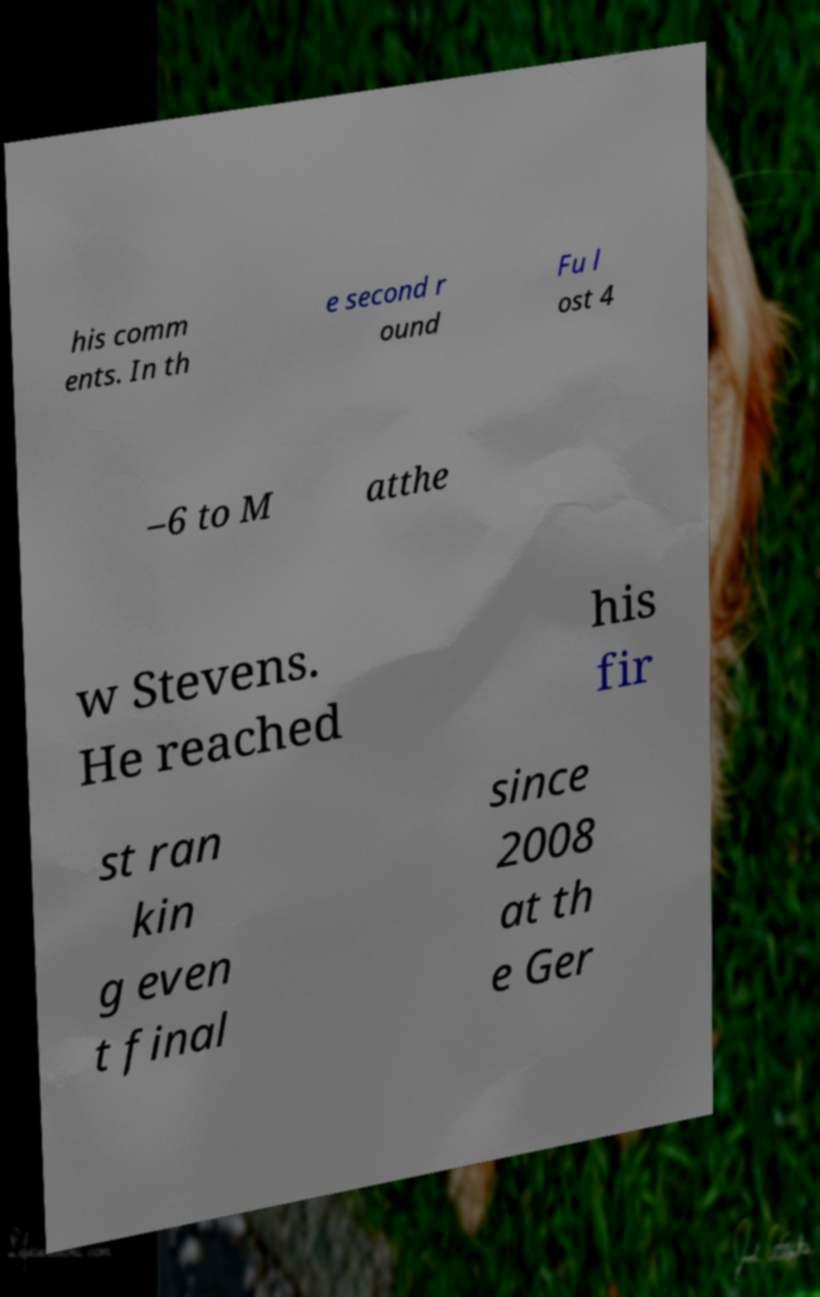Can you read and provide the text displayed in the image?This photo seems to have some interesting text. Can you extract and type it out for me? his comm ents. In th e second r ound Fu l ost 4 –6 to M atthe w Stevens. He reached his fir st ran kin g even t final since 2008 at th e Ger 